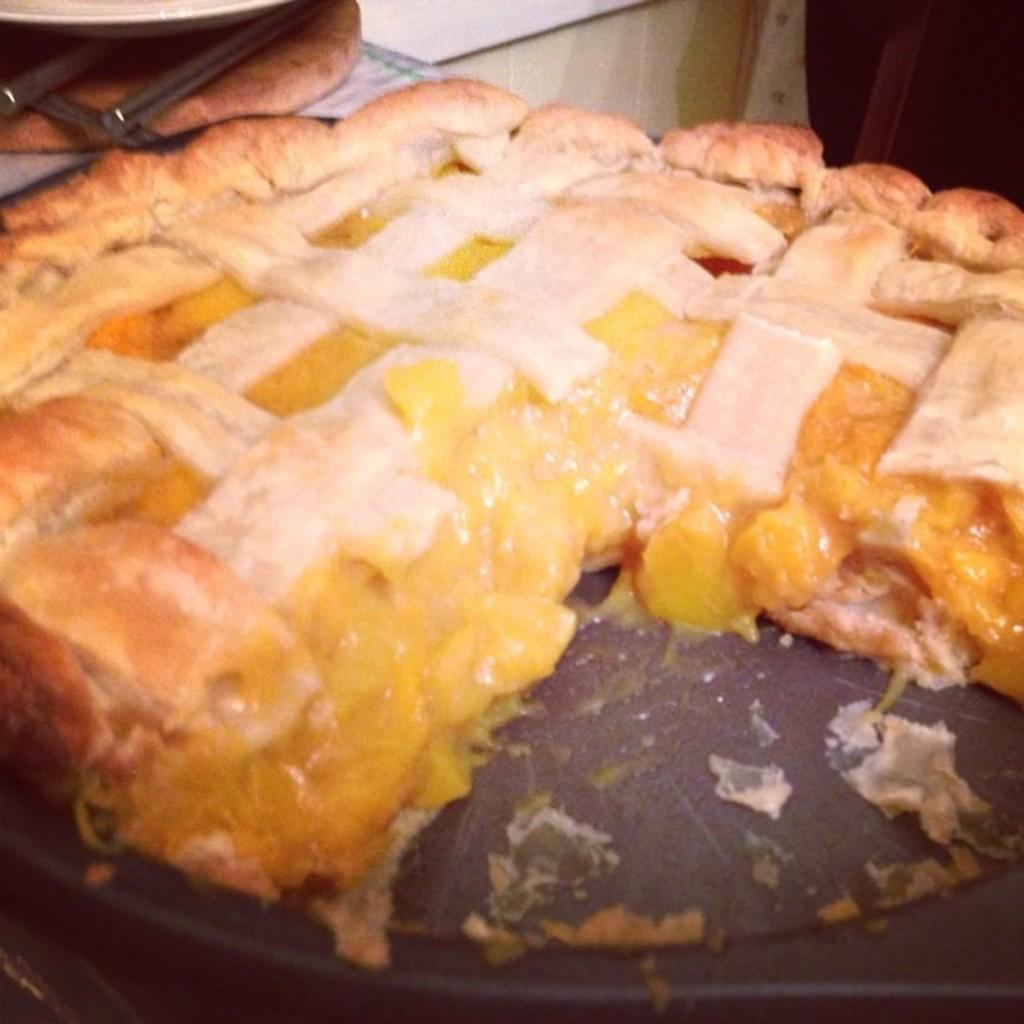Please provide a concise description of this image. In this image we can see a food item on a plate. 